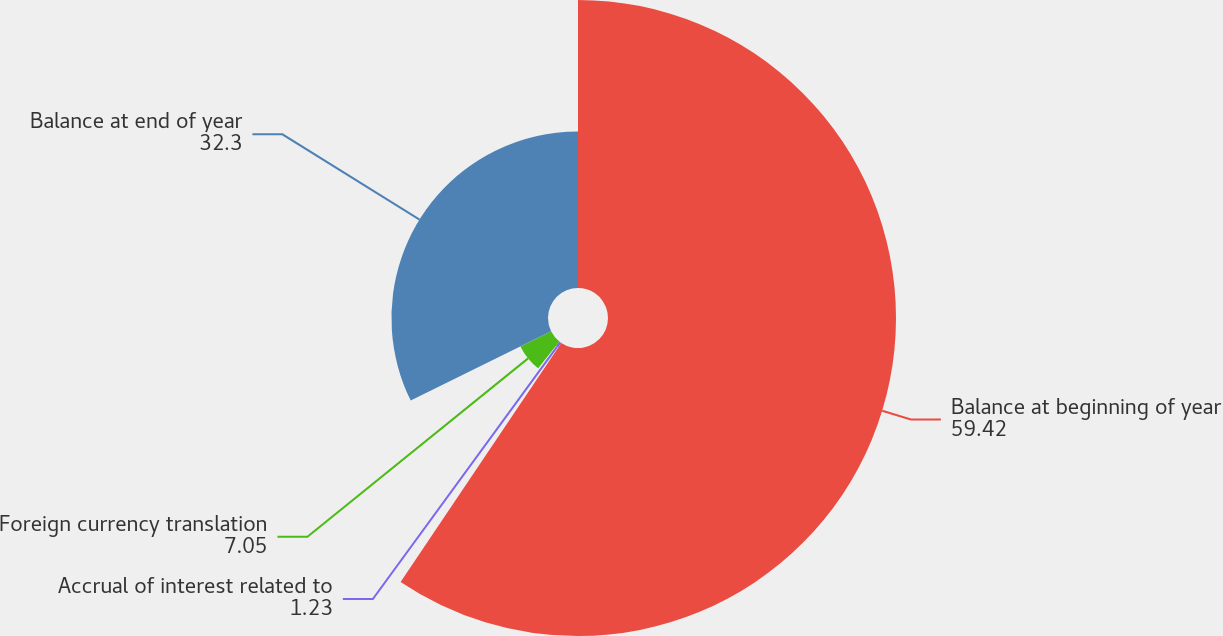<chart> <loc_0><loc_0><loc_500><loc_500><pie_chart><fcel>Balance at beginning of year<fcel>Accrual of interest related to<fcel>Foreign currency translation<fcel>Balance at end of year<nl><fcel>59.42%<fcel>1.23%<fcel>7.05%<fcel>32.3%<nl></chart> 